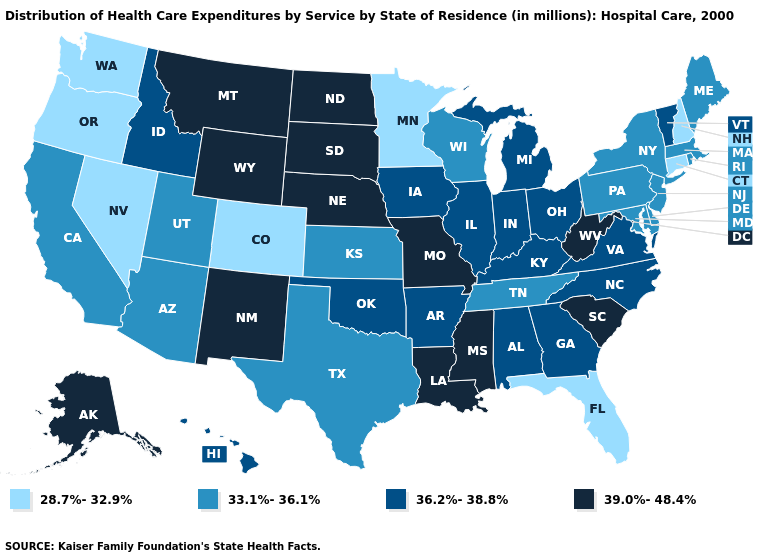Name the states that have a value in the range 28.7%-32.9%?
Write a very short answer. Colorado, Connecticut, Florida, Minnesota, Nevada, New Hampshire, Oregon, Washington. Name the states that have a value in the range 39.0%-48.4%?
Keep it brief. Alaska, Louisiana, Mississippi, Missouri, Montana, Nebraska, New Mexico, North Dakota, South Carolina, South Dakota, West Virginia, Wyoming. Does Idaho have the lowest value in the West?
Write a very short answer. No. Does Louisiana have a higher value than Tennessee?
Short answer required. Yes. What is the value of South Carolina?
Answer briefly. 39.0%-48.4%. Does the map have missing data?
Concise answer only. No. Name the states that have a value in the range 33.1%-36.1%?
Give a very brief answer. Arizona, California, Delaware, Kansas, Maine, Maryland, Massachusetts, New Jersey, New York, Pennsylvania, Rhode Island, Tennessee, Texas, Utah, Wisconsin. Does Indiana have a higher value than Montana?
Write a very short answer. No. Does Alabama have the highest value in the South?
Answer briefly. No. Name the states that have a value in the range 39.0%-48.4%?
Give a very brief answer. Alaska, Louisiana, Mississippi, Missouri, Montana, Nebraska, New Mexico, North Dakota, South Carolina, South Dakota, West Virginia, Wyoming. What is the lowest value in the USA?
Write a very short answer. 28.7%-32.9%. Is the legend a continuous bar?
Concise answer only. No. Among the states that border Virginia , which have the lowest value?
Answer briefly. Maryland, Tennessee. What is the lowest value in the USA?
Give a very brief answer. 28.7%-32.9%. 